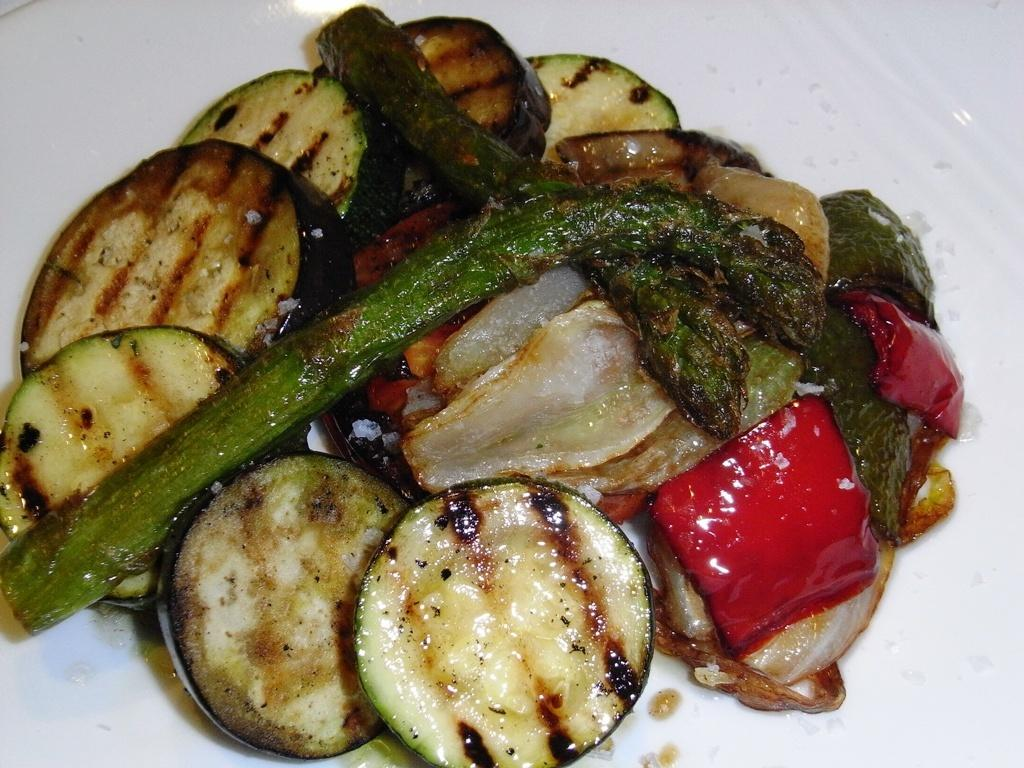What is on the plate that is visible in the image? There is food placed on a plate in the image. Where is the plate located in the image? The plate is located in the center of the image. How many visitors can be seen interacting with the sun in the image? There are no visitors or sun present in the image; it only features a plate with food. What type of wrist accessory is visible on the plate in the image? There is no wrist accessory present on the plate in the image. 